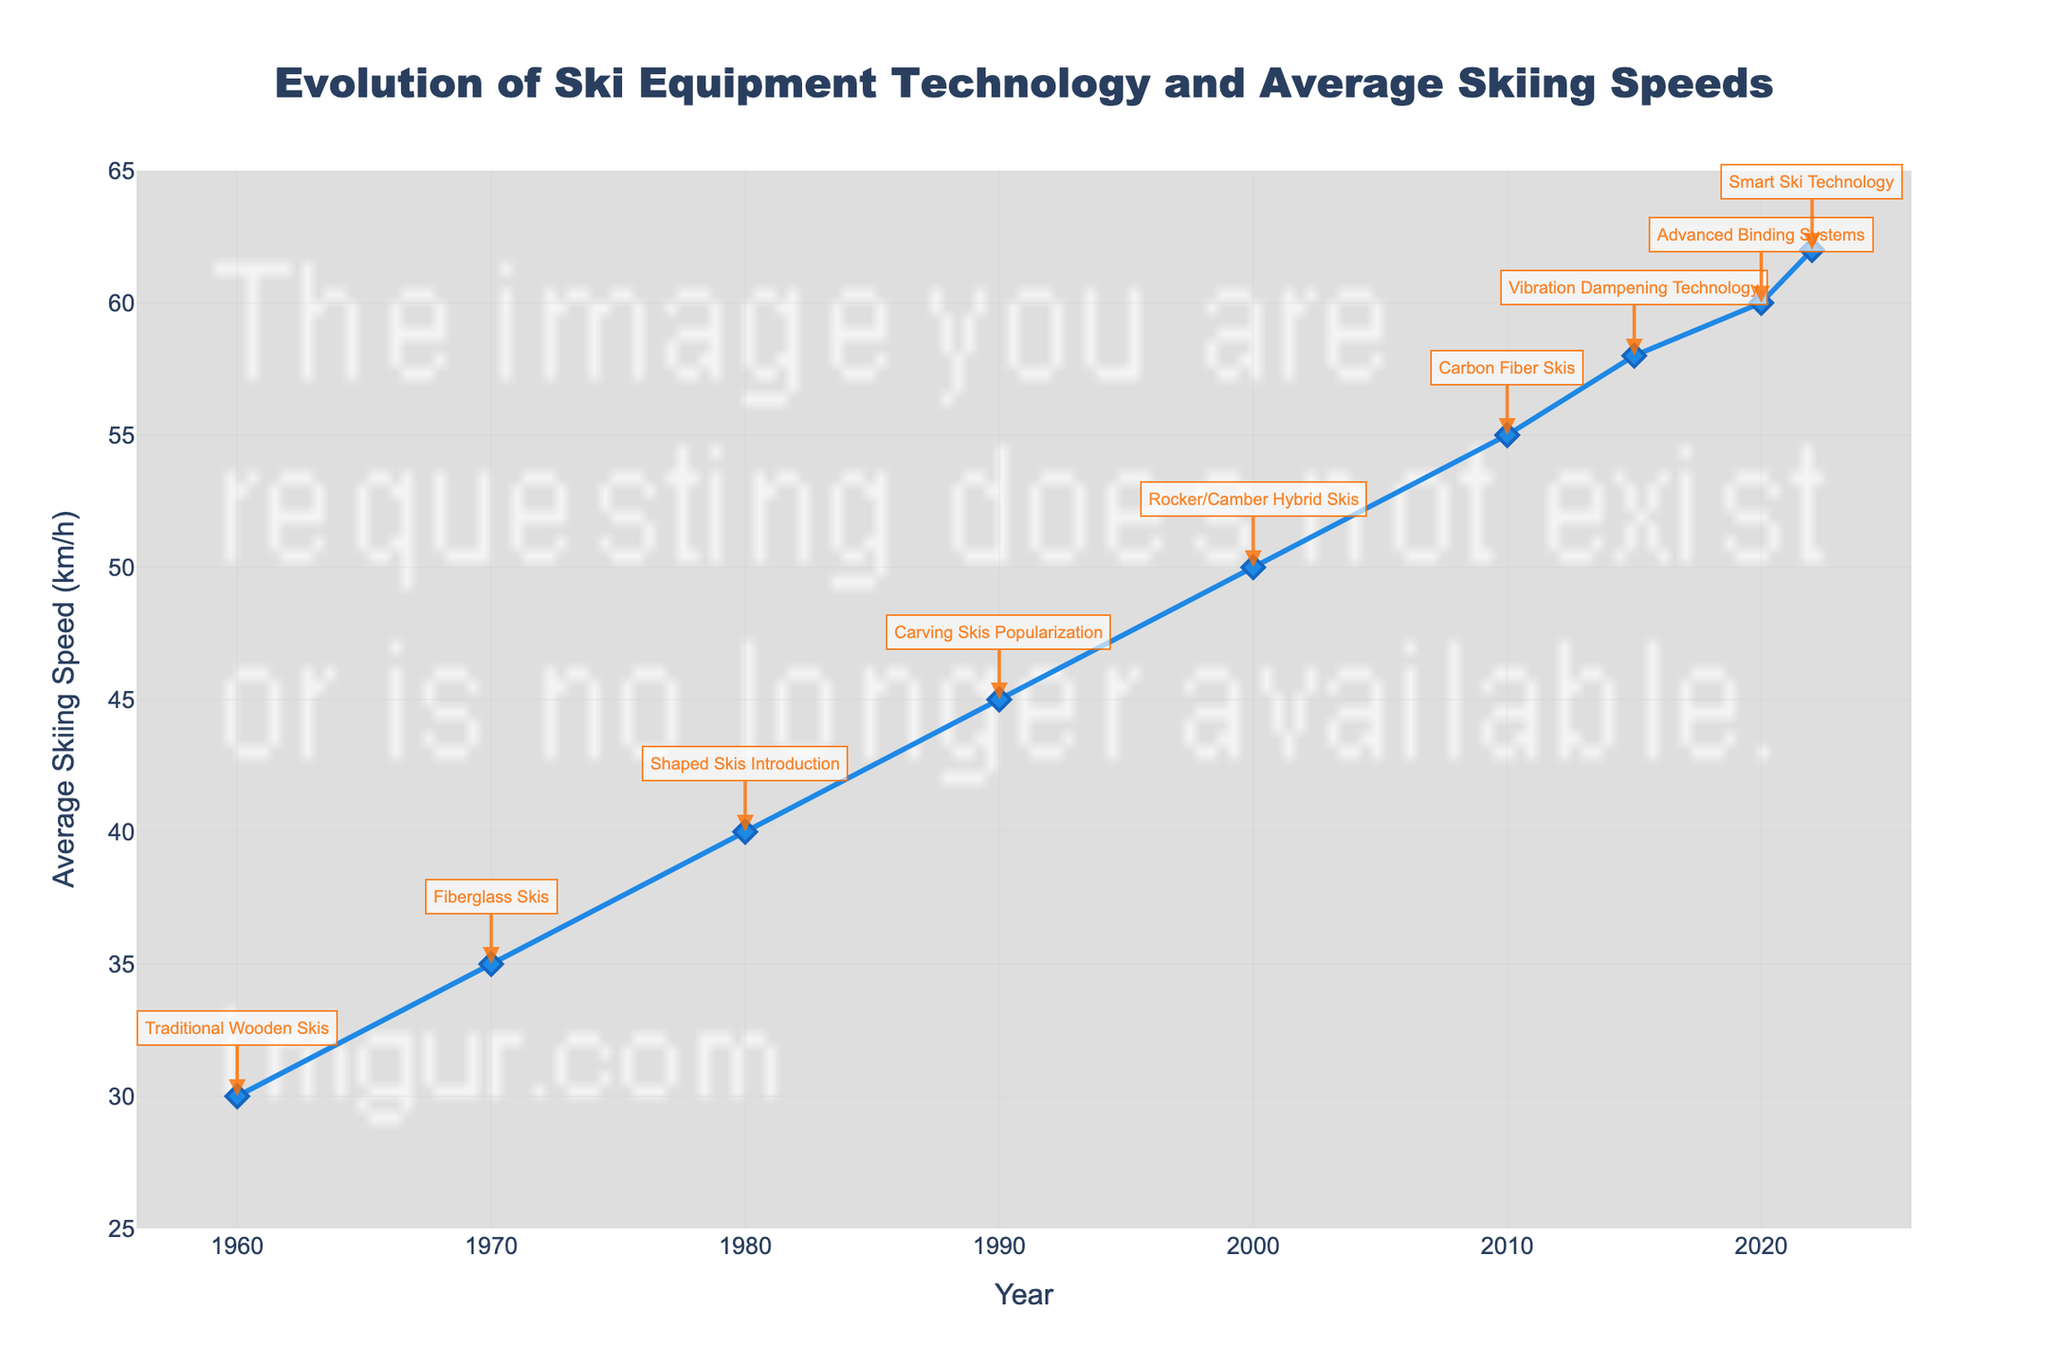What is the average skiing speed in 1970? The graph shows that in 1970, the marker for average skiing speed is positioned at 35 km/h, indicated by both the y-axis and the data point label.
Answer: 35 km/h Between which years did the average skiing speed see the greatest increase? To find the greatest increase, compare the differences in average skiing speeds between each consecutive pair of years. The increase is greatest between 2000 (50 km/h) and 2010 (55 km/h), a difference of 5 km/h.
Answer: 2000-2010 Which year introduced Carbon Fiber Skis and what was the average speed that year? Carbon Fiber Skis are introduced in 2010, as labeled on the graph. The average skiing speed that year is 55 km/h, which is indicated by the marker and the y-axis.
Answer: 2010, 55 km/h How much did the average skiing speed increase between the introduction of Carving Skis and Rocker/Camber Hybrid Skis? Carving Skis were popularized in 1990 with a speed of 45 km/h and Rocker/Camber Hybrid Skis were introduced in 2000 with a speed of 50 km/h. The increase is 50 - 45 = 5 km/h.
Answer: 5 km/h Which ski equipment technology saw the smallest increase in average skiing speed? The smallest increase is between 2010 (Carbon Fiber Skis, 55 km/h) and 2015 (Vibration Dampening Technology, 58 km/h) with an increase of 3 km/h.
Answer: Carbon Fiber Skis to Vibration Dampening Technology What is the average skiing speed when the most recent technology was introduced? The most recent technology, Smart Ski Technology, was introduced in 2022. The graph shows that the average skiing speed in 2022 is 62 km/h.
Answer: 62 km/h By how much did the average skiing speed improve from the 1960s to the present? The average skiing speed in 1960 was 30 km/h, and in 2022 it is 62 km/h. The improvement is 62 - 30 = 32 km/h.
Answer: 32 km/h Compare the average skiing speeds in the 1980s and the 1990s. Which decade had higher speeds and by how much? In the 1980s, the average speed was 40 km/h (Shaped Skis Introduction). In the 1990s, it was 45 km/h (Carving Skis Popularization). The 1990s had higher speeds by 45 - 40 = 5 km/h.
Answer: 1990s, 5 km/h 